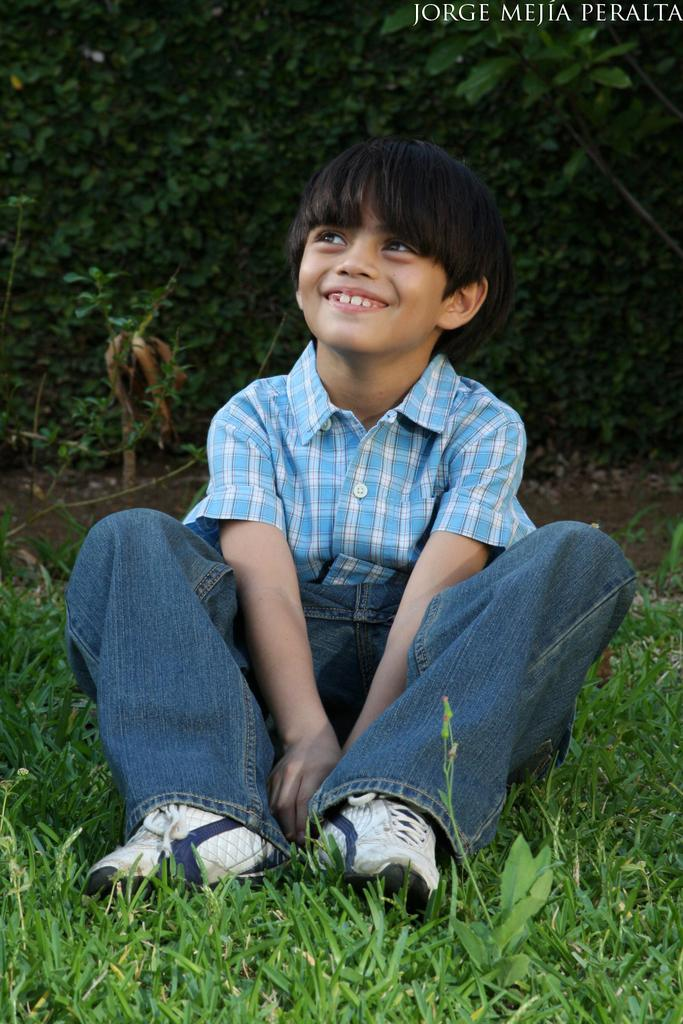Who is in the image? There is a boy in the image. What is the boy doing in the image? The boy is sitting on the grass. What is the boy's facial expression in the image? The boy is smiling. What can be seen in the background of the image? There are trees in the background of the image. What is present in the top right corner of the image? There is some text on the top right of the image. What type of patch is the boy wearing on his arm in the image? There is no patch visible on the boy's arm in the image. 